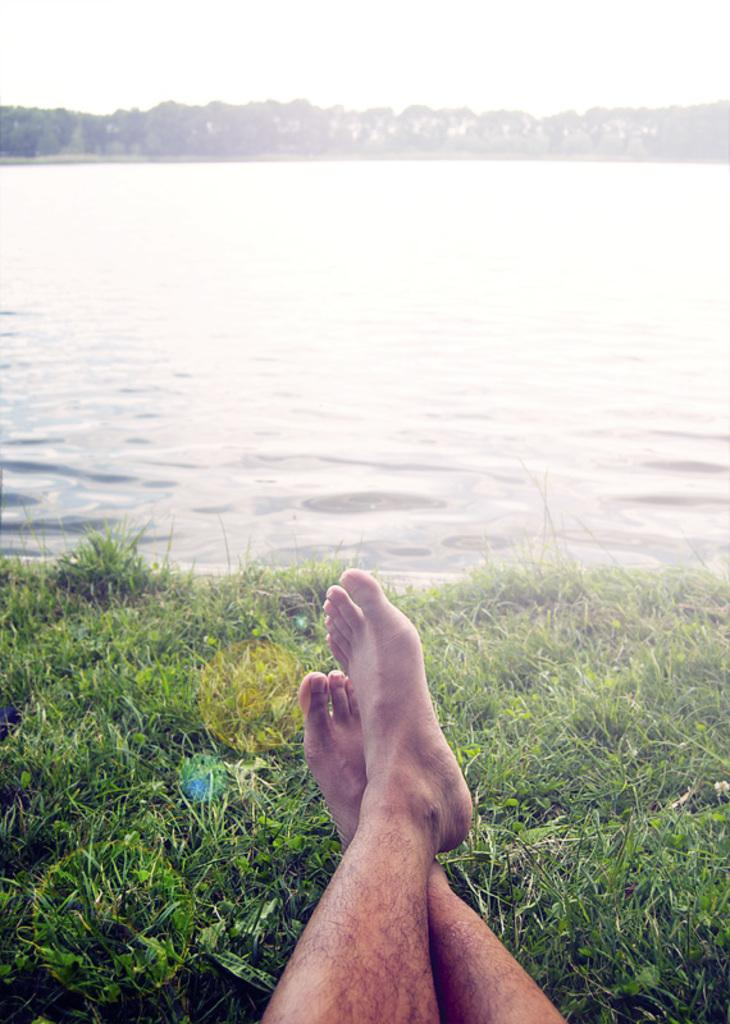What type of natural feature is present in the image? There is a lake in the image. Can you describe the person in the image? There is a person sitting on the grass in the image. What type of road can be seen leading to the lake in the image? There is no road visible in the image; it only features a lake and a person sitting on the grass. Can you tell me how many tigers are swimming in the lake in the image? There are no tigers present in the image; it only features a lake and a person sitting on the grass. 